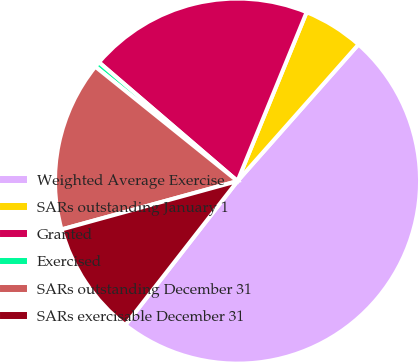<chart> <loc_0><loc_0><loc_500><loc_500><pie_chart><fcel>Weighted Average Exercise<fcel>SARs outstanding January 1<fcel>Granted<fcel>Exercised<fcel>SARs outstanding December 31<fcel>SARs exercisable December 31<nl><fcel>49.0%<fcel>5.35%<fcel>19.9%<fcel>0.5%<fcel>15.05%<fcel>10.2%<nl></chart> 